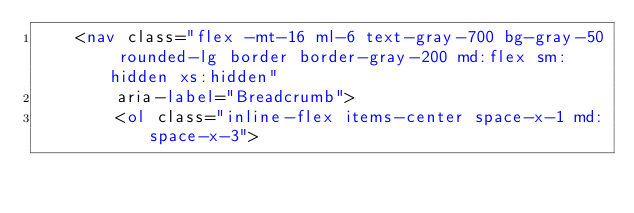<code> <loc_0><loc_0><loc_500><loc_500><_HTML_>    <nav class="flex -mt-16 ml-6 text-gray-700 bg-gray-50 rounded-lg border border-gray-200 md:flex sm:hidden xs:hidden"
        aria-label="Breadcrumb">
        <ol class="inline-flex items-center space-x-1 md:space-x-3"></code> 